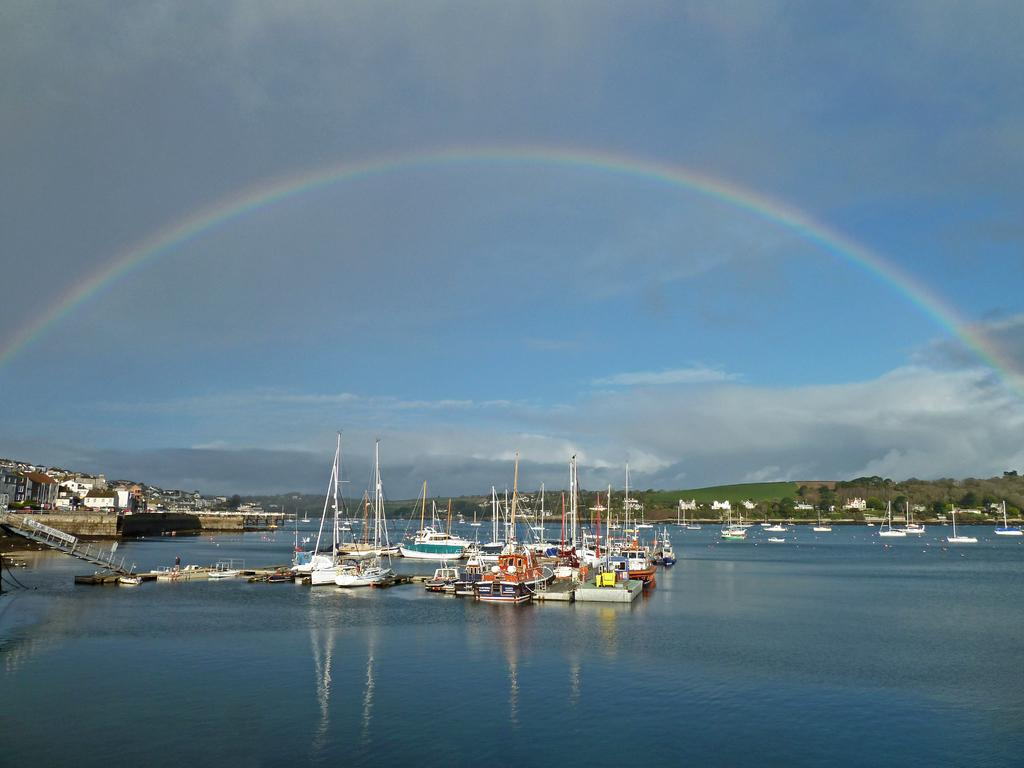What is the primary subject of the image? There are many boats in the image. What is located at the bottom of the image? There is water at the bottom of the image. What can be seen in the background of the image? There are mountains in the background of the image. What is visible in the sky in the image? A rainbow is visible in the sky, along with clouds. Where is the zipper located on the boat in the image? There is no zipper present on any of the boats in the image. What type of tin can be seen floating in the water? There is no tin visible in the water in the image. 